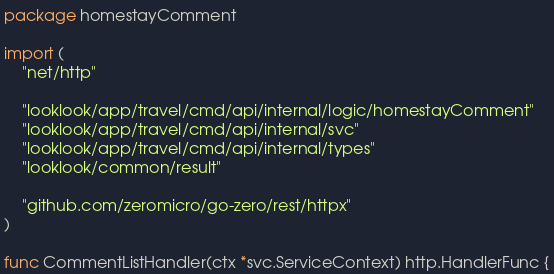<code> <loc_0><loc_0><loc_500><loc_500><_Go_>package homestayComment

import (
	"net/http"

	"looklook/app/travel/cmd/api/internal/logic/homestayComment"
	"looklook/app/travel/cmd/api/internal/svc"
	"looklook/app/travel/cmd/api/internal/types"
	"looklook/common/result"

	"github.com/zeromicro/go-zero/rest/httpx"
)

func CommentListHandler(ctx *svc.ServiceContext) http.HandlerFunc {</code> 